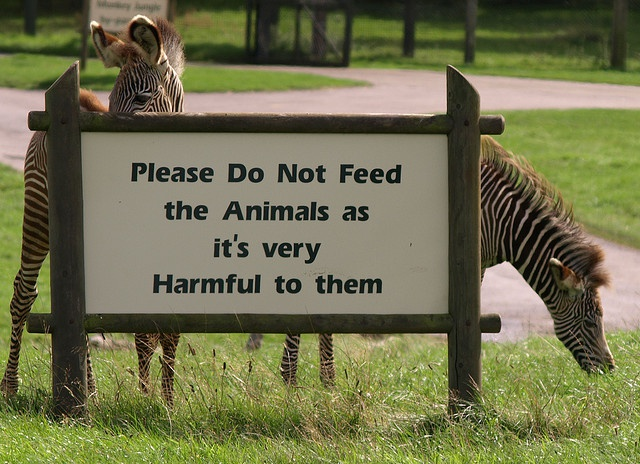Describe the objects in this image and their specific colors. I can see zebra in black and gray tones and zebra in black, gray, and maroon tones in this image. 